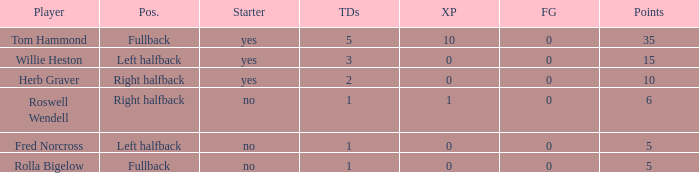What is the lowest number of touchdowns for left halfback WIllie Heston who has more than 15 points? None. 